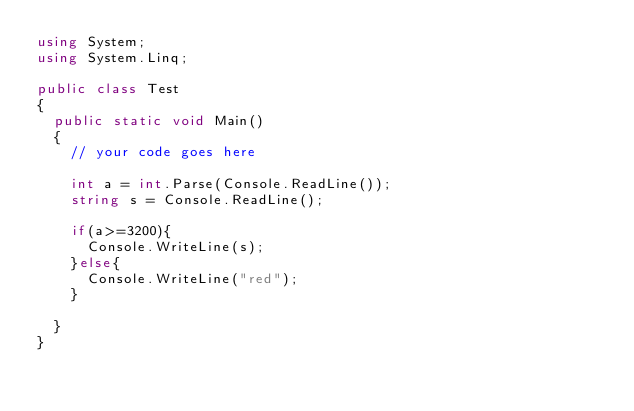Convert code to text. <code><loc_0><loc_0><loc_500><loc_500><_C#_>using System;
using System.Linq;

public class Test
{
	public static void Main()
	{
		// your code goes here
		
		int a = int.Parse(Console.ReadLine());
		string s = Console.ReadLine();
		
		if(a>=3200){
			Console.WriteLine(s);
		}else{
			Console.WriteLine("red");
		}
		
	}
}</code> 